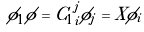<formula> <loc_0><loc_0><loc_500><loc_500>\phi _ { 1 } \phi = { C _ { 1 } } _ { i } ^ { j } \phi _ { j } = X \phi _ { i }</formula> 